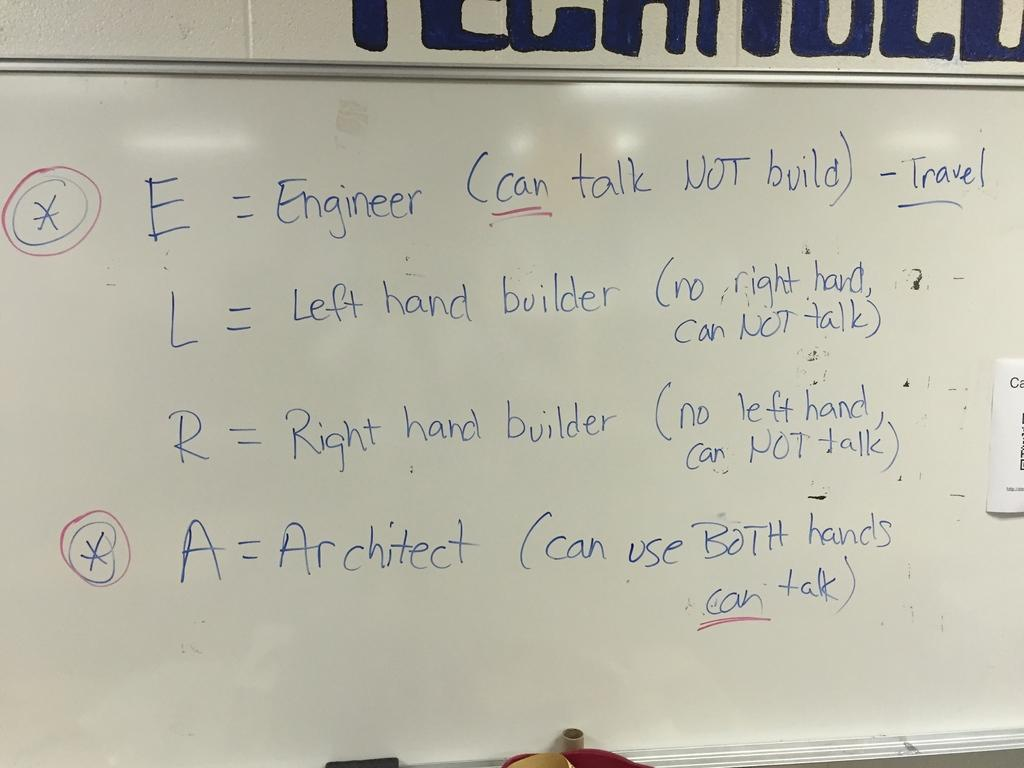<image>
Write a terse but informative summary of the picture. The acronym ELRA is written on a whiteboard, and it stands for Engineer, Right and Left handed builders, and Architect. 